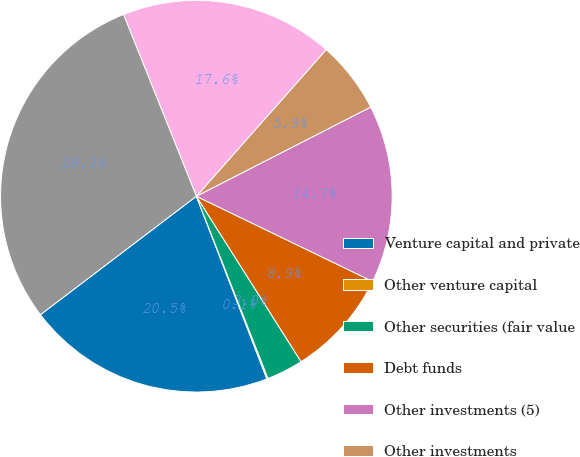Convert chart to OTSL. <chart><loc_0><loc_0><loc_500><loc_500><pie_chart><fcel>Venture capital and private<fcel>Other venture capital<fcel>Other securities (fair value<fcel>Debt funds<fcel>Other investments (5)<fcel>Other investments<fcel>Investments in qualified<fcel>Total non-marketable and other<nl><fcel>20.52%<fcel>0.1%<fcel>3.02%<fcel>8.85%<fcel>14.69%<fcel>5.94%<fcel>17.6%<fcel>29.27%<nl></chart> 